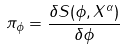<formula> <loc_0><loc_0><loc_500><loc_500>\pi _ { \phi } = \frac { \delta S ( \phi , X ^ { \alpha } ) } { \delta \phi }</formula> 